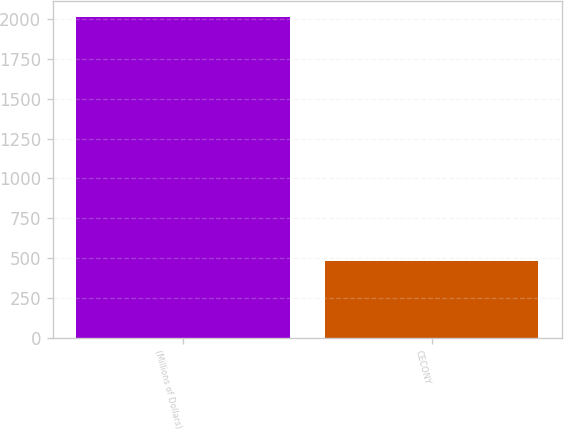<chart> <loc_0><loc_0><loc_500><loc_500><bar_chart><fcel>(Millions of Dollars)<fcel>CECONY<nl><fcel>2012<fcel>479<nl></chart> 